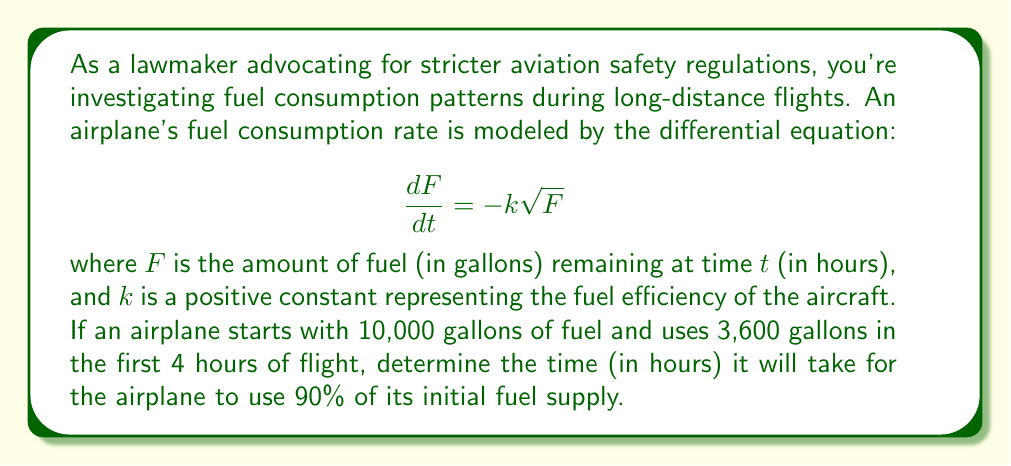Teach me how to tackle this problem. Let's approach this problem step-by-step:

1) First, we need to solve the differential equation. We can separate variables:

   $$\frac{dF}{dt} = -k\sqrt{F}$$
   $$\frac{dF}{\sqrt{F}} = -k dt$$

2) Integrating both sides:

   $$\int \frac{dF}{\sqrt{F}} = -k \int dt$$
   $$2\sqrt{F} = -kt + C$$

3) We can find $C$ using the initial condition $F(0) = 10000$:

   $$2\sqrt{10000} = C$$
   $$C = 200$$

4) So our general solution is:

   $$2\sqrt{F} = -kt + 200$$
   $$F = (\frac{200-kt}{2})^2$$

5) Now, we can use the information that 3,600 gallons are used in 4 hours to find $k$:

   $$10000 - 3600 = (\frac{200-4k}{2})^2$$
   $$6400 = (\frac{200-4k}{2})^2$$
   $$160 = \frac{200-4k}{2}$$
   $$320 = 200-4k$$
   $$4k = -120$$
   $$k = -30$$

6) Now that we have $k$, we can find the time it takes to use 90% of the fuel:

   $$1000 = (\frac{200-(-30)t}{2})^2$$
   $$\sqrt{1000} = \frac{200+30t}{2}$$
   $$63.2 = 100+15t$$
   $$-36.8 = 15t$$
   $$t = \frac{-36.8}{15} \approx 2.45$$

Therefore, it will take approximately 2.45 hours for the airplane to use 90% of its initial fuel supply.
Answer: Approximately 2.45 hours 